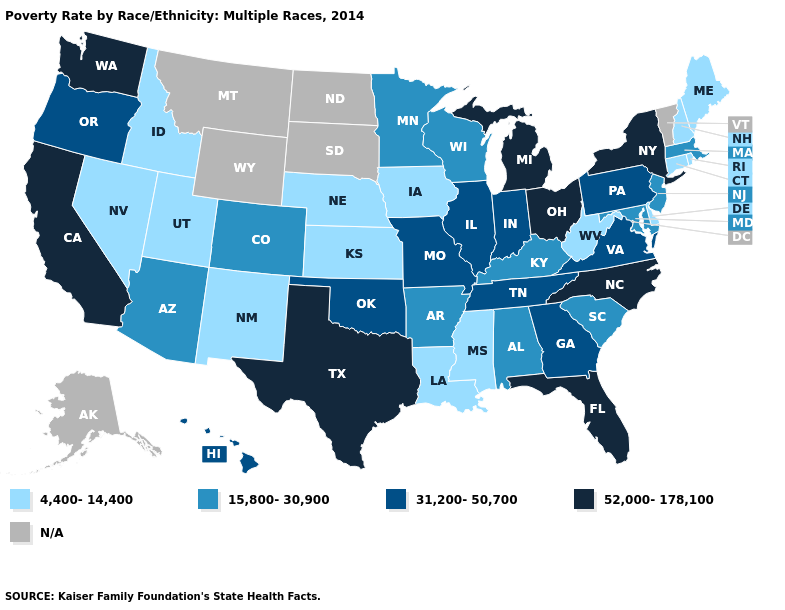What is the highest value in the USA?
Write a very short answer. 52,000-178,100. Does Illinois have the lowest value in the USA?
Give a very brief answer. No. What is the highest value in states that border New York?
Keep it brief. 31,200-50,700. Does Colorado have the lowest value in the USA?
Be succinct. No. Name the states that have a value in the range 15,800-30,900?
Give a very brief answer. Alabama, Arizona, Arkansas, Colorado, Kentucky, Maryland, Massachusetts, Minnesota, New Jersey, South Carolina, Wisconsin. Name the states that have a value in the range N/A?
Give a very brief answer. Alaska, Montana, North Dakota, South Dakota, Vermont, Wyoming. Name the states that have a value in the range 31,200-50,700?
Concise answer only. Georgia, Hawaii, Illinois, Indiana, Missouri, Oklahoma, Oregon, Pennsylvania, Tennessee, Virginia. Name the states that have a value in the range 4,400-14,400?
Quick response, please. Connecticut, Delaware, Idaho, Iowa, Kansas, Louisiana, Maine, Mississippi, Nebraska, Nevada, New Hampshire, New Mexico, Rhode Island, Utah, West Virginia. Does New Mexico have the lowest value in the USA?
Quick response, please. Yes. Name the states that have a value in the range 31,200-50,700?
Short answer required. Georgia, Hawaii, Illinois, Indiana, Missouri, Oklahoma, Oregon, Pennsylvania, Tennessee, Virginia. Does Illinois have the lowest value in the MidWest?
Be succinct. No. Among the states that border Oklahoma , does Colorado have the lowest value?
Be succinct. No. Among the states that border Wisconsin , does Michigan have the lowest value?
Short answer required. No. 